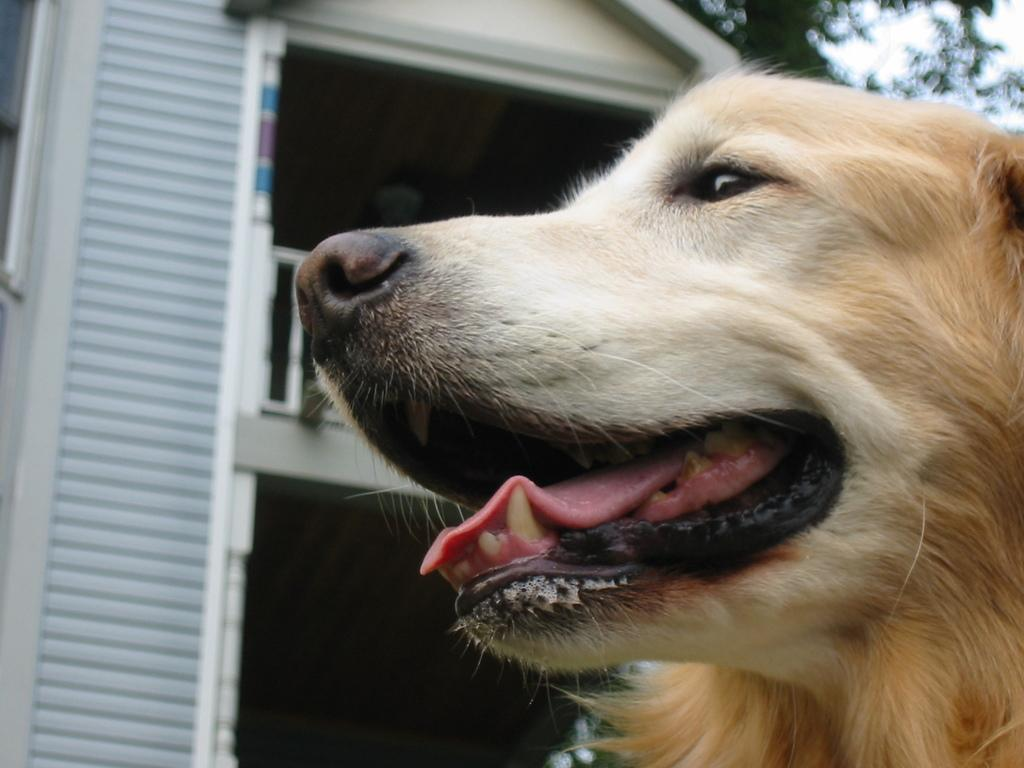What type of animal is in the image? There is a brown dog in the image. Where is the dog located in the image? The dog is in the right corner of the image. What is near the dog in the image? There is a building beside the dog in the image. What language is the dog speaking in the image? Dogs do not speak human languages, so it is not possible to determine the language the dog is speaking in the image. 